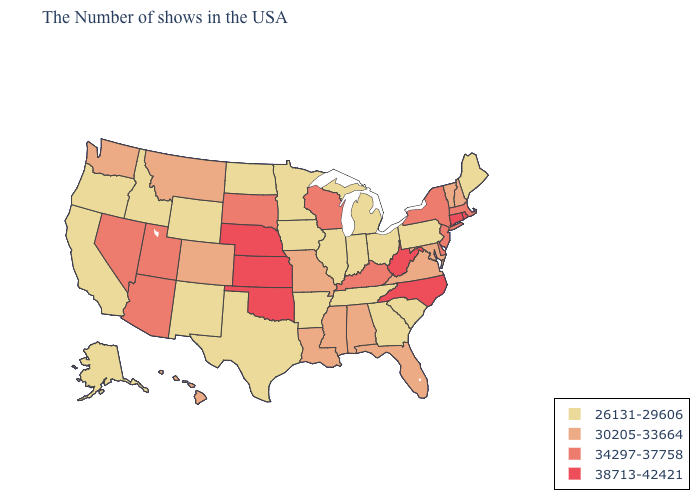Does Connecticut have the highest value in the Northeast?
Keep it brief. Yes. Name the states that have a value in the range 30205-33664?
Write a very short answer. New Hampshire, Vermont, Maryland, Virginia, Florida, Alabama, Mississippi, Louisiana, Missouri, Colorado, Montana, Washington, Hawaii. Name the states that have a value in the range 38713-42421?
Be succinct. Rhode Island, Connecticut, North Carolina, West Virginia, Kansas, Nebraska, Oklahoma. Which states have the lowest value in the USA?
Write a very short answer. Maine, Pennsylvania, South Carolina, Ohio, Georgia, Michigan, Indiana, Tennessee, Illinois, Arkansas, Minnesota, Iowa, Texas, North Dakota, Wyoming, New Mexico, Idaho, California, Oregon, Alaska. Name the states that have a value in the range 34297-37758?
Answer briefly. Massachusetts, New York, New Jersey, Delaware, Kentucky, Wisconsin, South Dakota, Utah, Arizona, Nevada. Name the states that have a value in the range 38713-42421?
Be succinct. Rhode Island, Connecticut, North Carolina, West Virginia, Kansas, Nebraska, Oklahoma. Does Missouri have the highest value in the MidWest?
Answer briefly. No. What is the value of Wyoming?
Give a very brief answer. 26131-29606. Among the states that border Connecticut , which have the lowest value?
Quick response, please. Massachusetts, New York. Does Maine have a higher value than Colorado?
Answer briefly. No. What is the value of Louisiana?
Short answer required. 30205-33664. Does Nebraska have the highest value in the USA?
Concise answer only. Yes. What is the value of Ohio?
Write a very short answer. 26131-29606. Among the states that border Texas , does Louisiana have the highest value?
Keep it brief. No. What is the value of North Carolina?
Give a very brief answer. 38713-42421. 